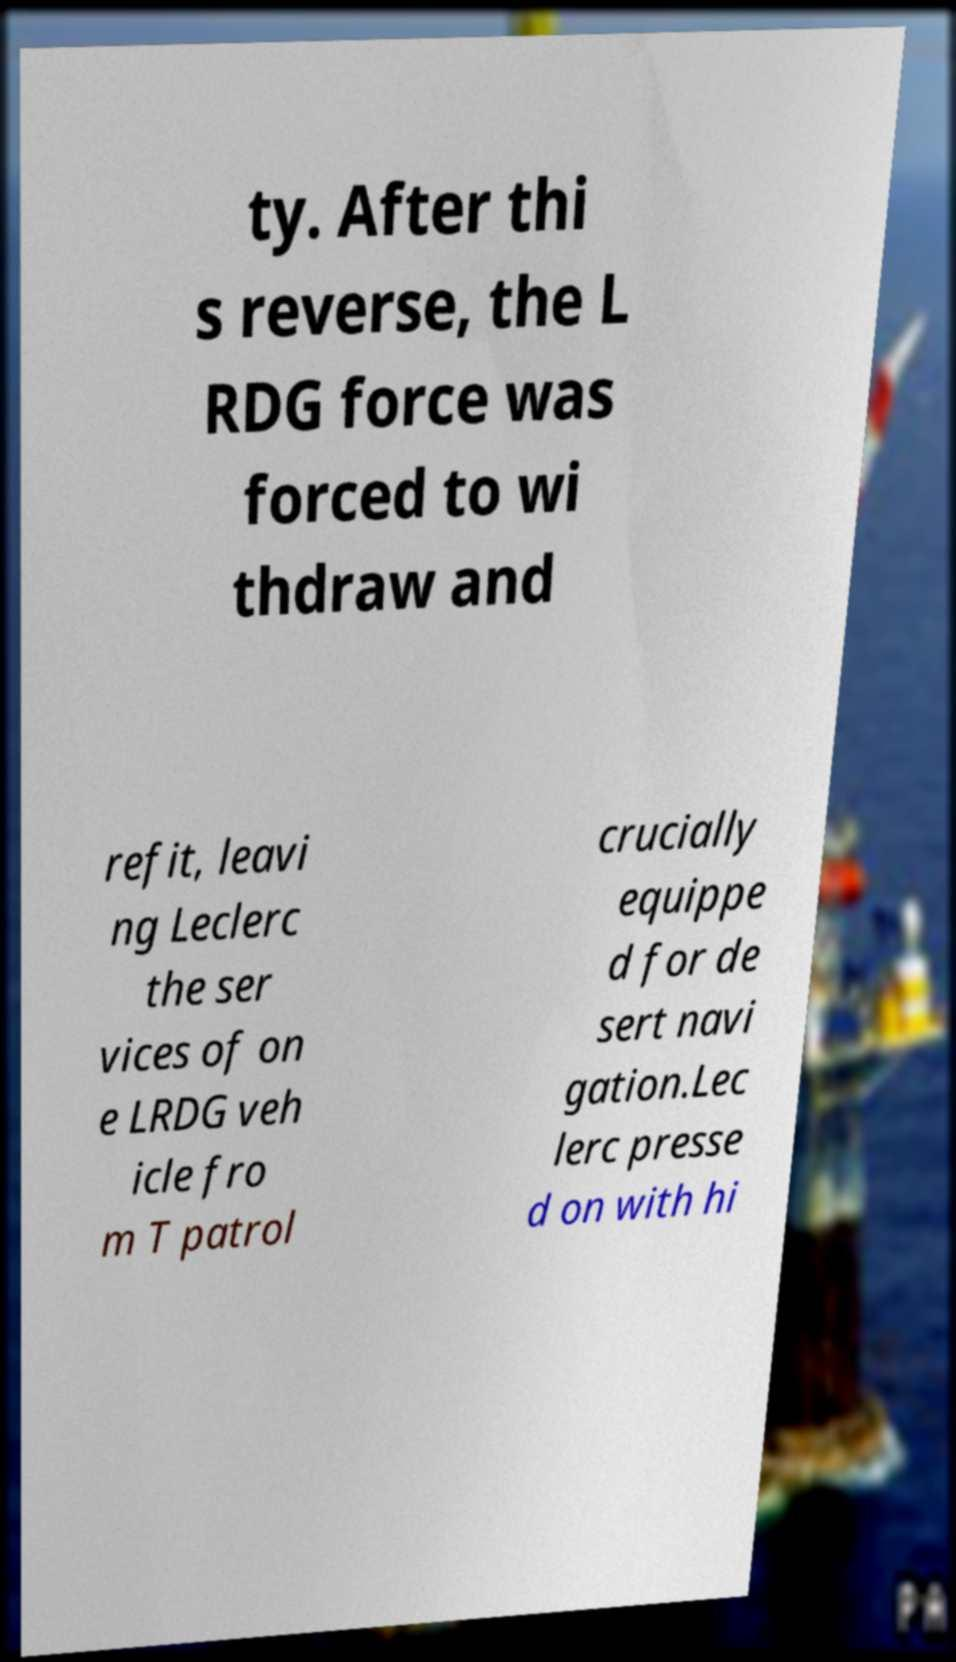Can you read and provide the text displayed in the image?This photo seems to have some interesting text. Can you extract and type it out for me? ty. After thi s reverse, the L RDG force was forced to wi thdraw and refit, leavi ng Leclerc the ser vices of on e LRDG veh icle fro m T patrol crucially equippe d for de sert navi gation.Lec lerc presse d on with hi 